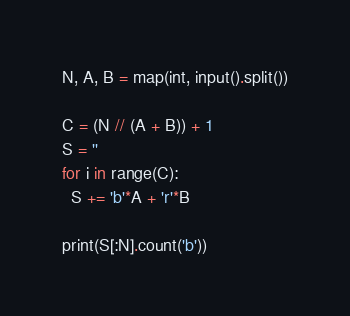<code> <loc_0><loc_0><loc_500><loc_500><_Python_>N, A, B = map(int, input().split())

C = (N // (A + B)) + 1
S = ''
for i in range(C):
  S += 'b'*A + 'r'*B
  
print(S[:N].count('b'))</code> 